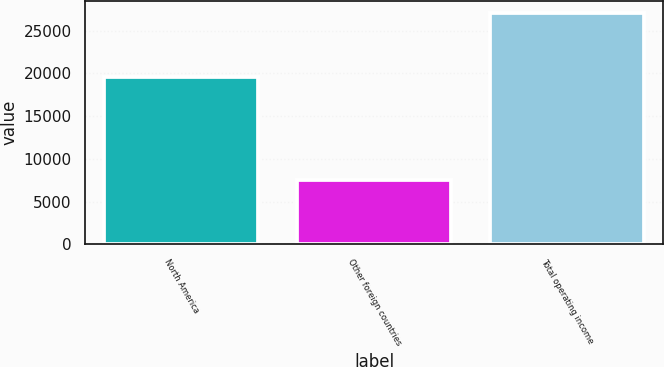Convert chart to OTSL. <chart><loc_0><loc_0><loc_500><loc_500><bar_chart><fcel>North America<fcel>Other foreign countries<fcel>Total operating income<nl><fcel>19567<fcel>7515<fcel>27082<nl></chart> 